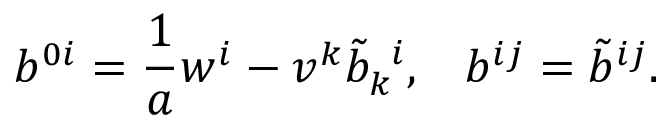<formula> <loc_0><loc_0><loc_500><loc_500>b ^ { 0 i } = \frac { 1 } { a } w ^ { i } - v ^ { k } { \tilde { b } } _ { k } ^ { \, i } , \, b ^ { i j } = { \tilde { b } } ^ { i j } .</formula> 